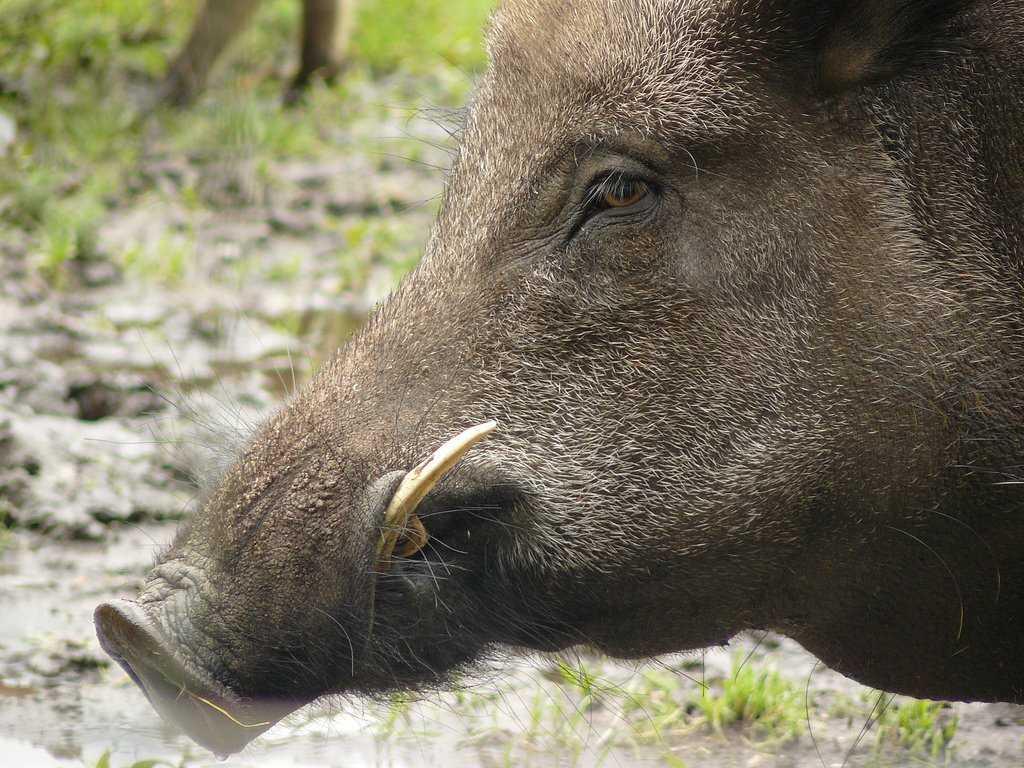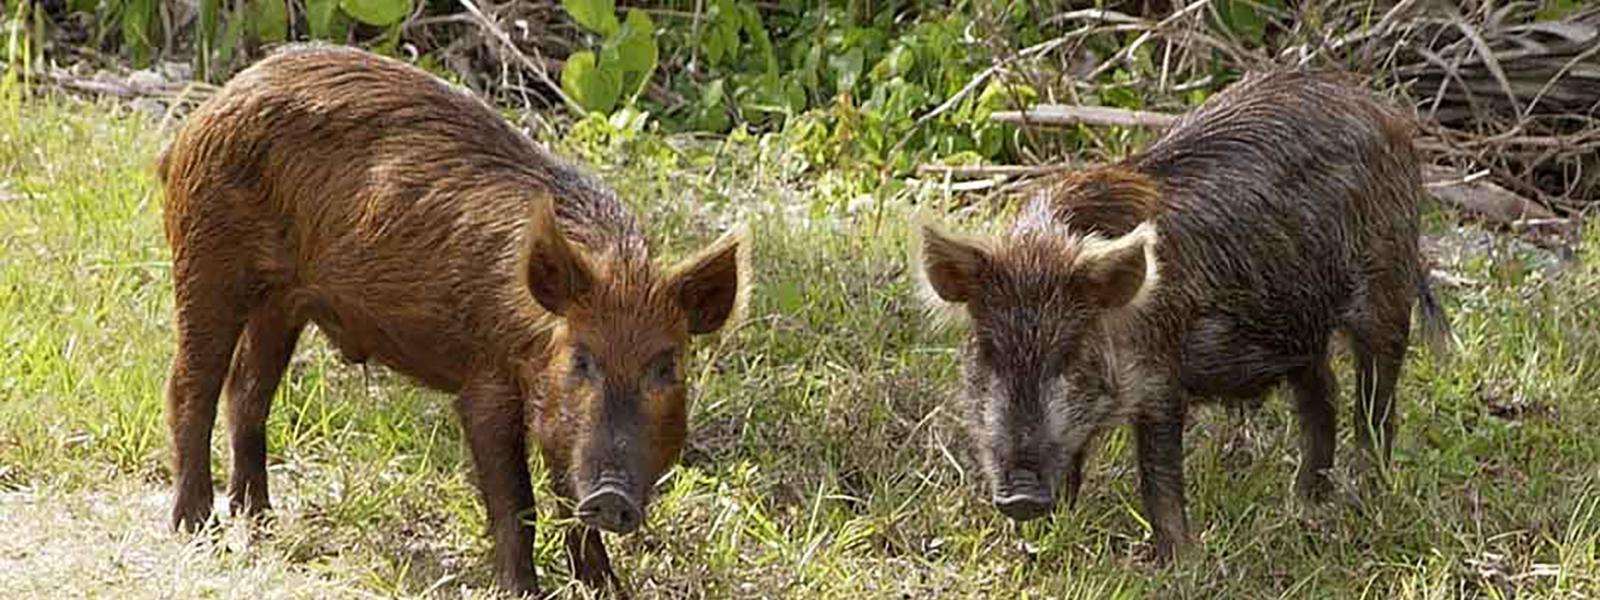The first image is the image on the left, the second image is the image on the right. Considering the images on both sides, is "There are at most two wild boars" valid? Answer yes or no. No. 